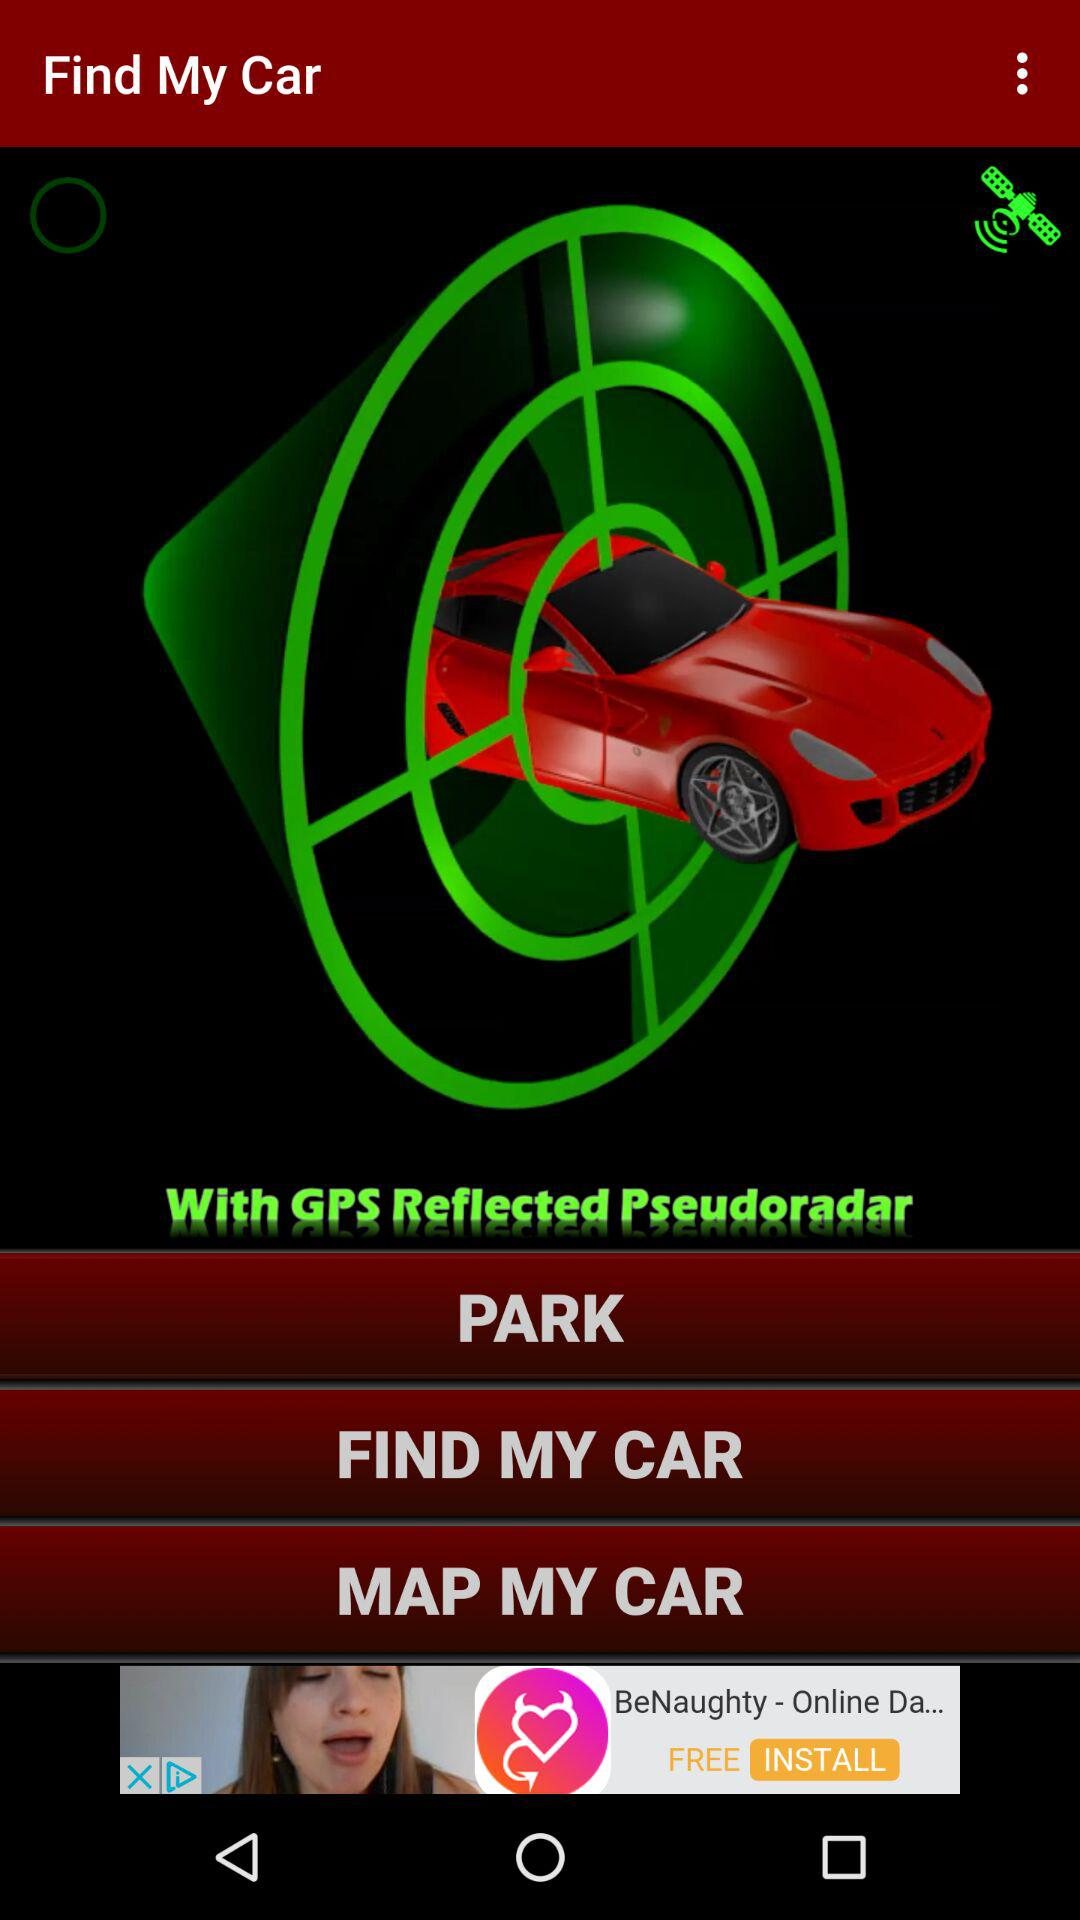What is the name of the application? The application name is "Find My Car". 